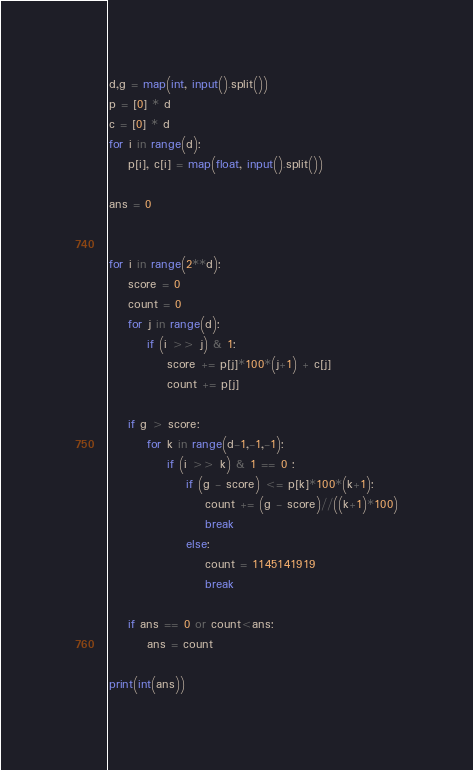Convert code to text. <code><loc_0><loc_0><loc_500><loc_500><_Python_>d,g = map(int, input().split())
p = [0] * d
c = [0] * d
for i in range(d):
    p[i], c[i] = map(float, input().split())
    
ans = 0

    
for i in range(2**d):
    score = 0
    count = 0
    for j in range(d):
        if (i >> j) & 1:
            score += p[j]*100*(j+1) + c[j]
            count += p[j]
            
    if g > score:
        for k in range(d-1,-1,-1):
            if (i >> k) & 1 == 0 :
                if (g - score) <= p[k]*100*(k+1):
                    count += (g - score)//((k+1)*100)
                    break
                else:
                    count = 1145141919
                    break
                    
    if ans == 0 or count<ans:
        ans = count

print(int(ans))</code> 